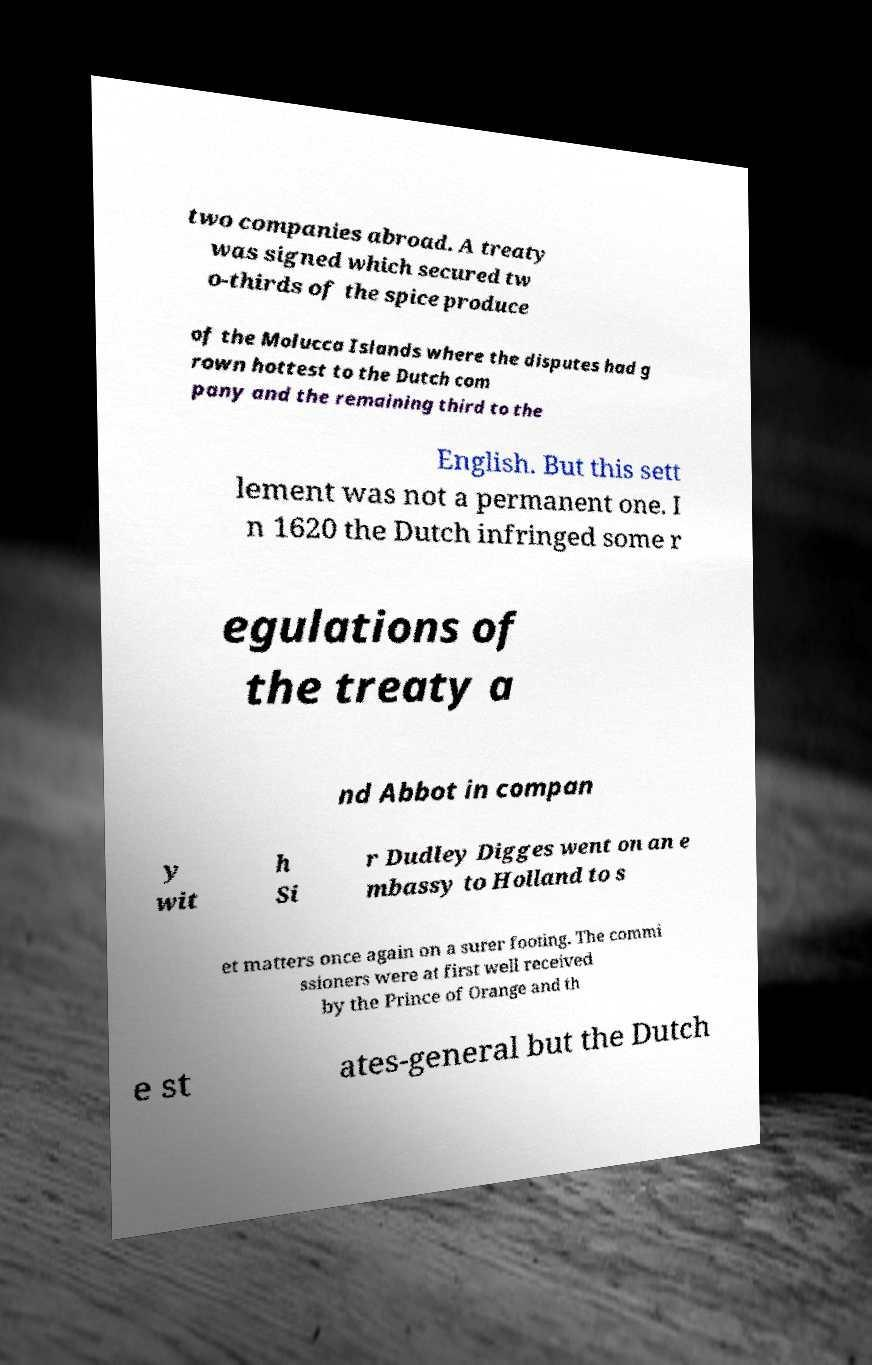Can you read and provide the text displayed in the image?This photo seems to have some interesting text. Can you extract and type it out for me? two companies abroad. A treaty was signed which secured tw o-thirds of the spice produce of the Molucca Islands where the disputes had g rown hottest to the Dutch com pany and the remaining third to the English. But this sett lement was not a permanent one. I n 1620 the Dutch infringed some r egulations of the treaty a nd Abbot in compan y wit h Si r Dudley Digges went on an e mbassy to Holland to s et matters once again on a surer footing. The commi ssioners were at first well received by the Prince of Orange and th e st ates-general but the Dutch 